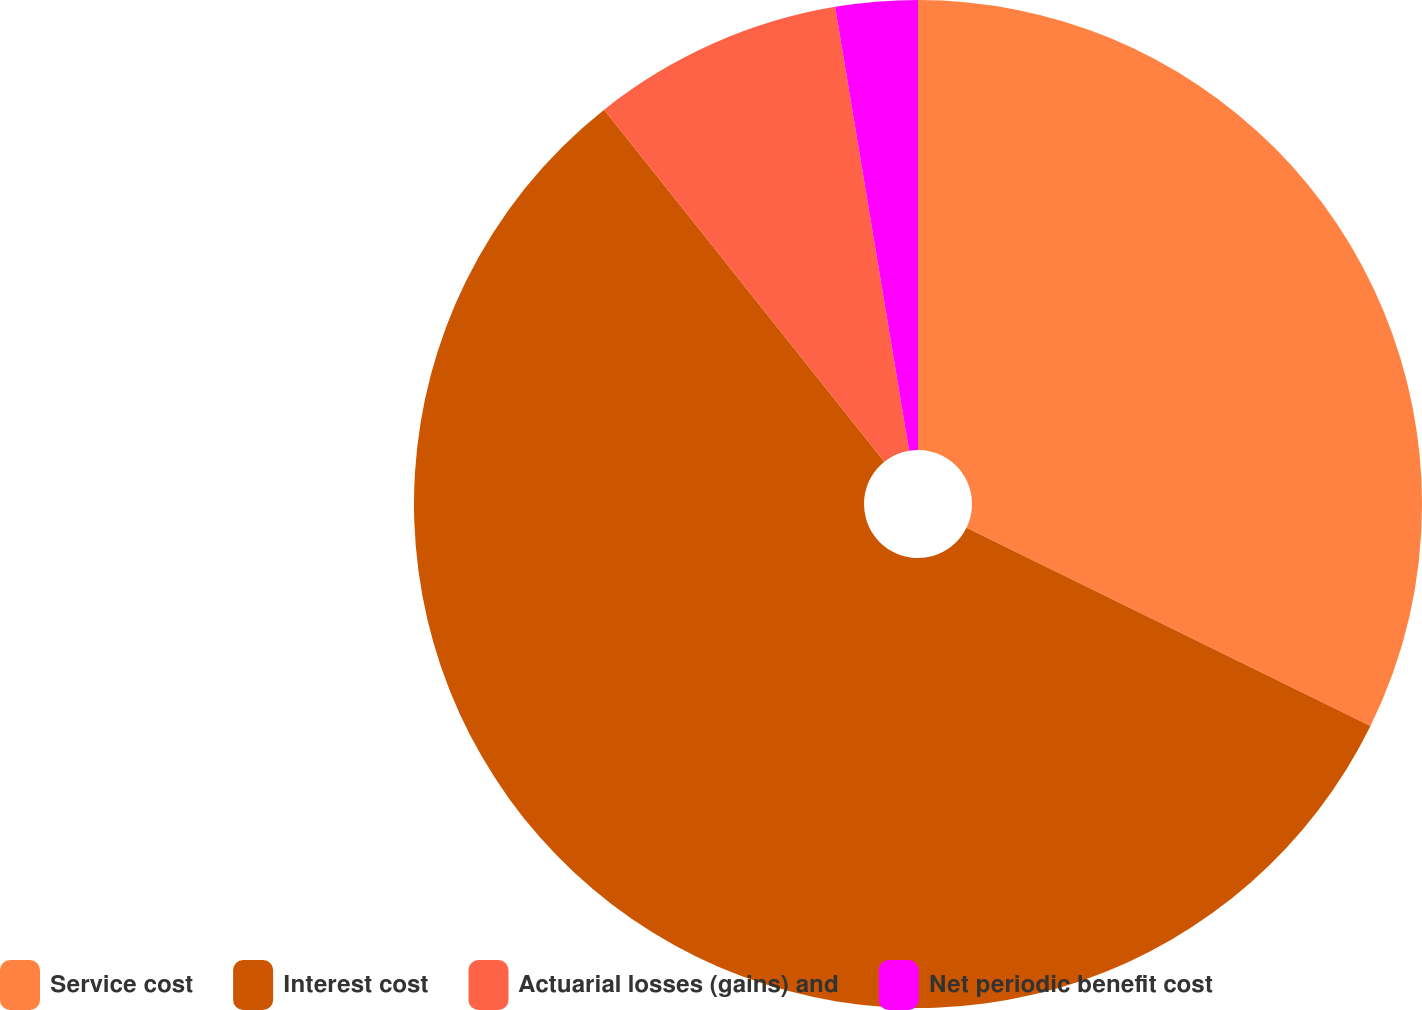Convert chart to OTSL. <chart><loc_0><loc_0><loc_500><loc_500><pie_chart><fcel>Service cost<fcel>Interest cost<fcel>Actuarial losses (gains) and<fcel>Net periodic benefit cost<nl><fcel>32.26%<fcel>57.04%<fcel>8.07%<fcel>2.63%<nl></chart> 